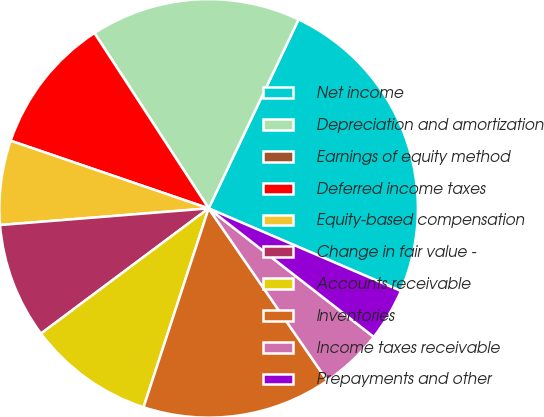Convert chart. <chart><loc_0><loc_0><loc_500><loc_500><pie_chart><fcel>Net income<fcel>Depreciation and amortization<fcel>Earnings of equity method<fcel>Deferred income taxes<fcel>Equity-based compensation<fcel>Change in fair value -<fcel>Accounts receivable<fcel>Inventories<fcel>Income taxes receivable<fcel>Prepayments and other<nl><fcel>24.39%<fcel>16.26%<fcel>0.0%<fcel>10.57%<fcel>6.51%<fcel>8.94%<fcel>9.76%<fcel>14.63%<fcel>4.88%<fcel>4.07%<nl></chart> 